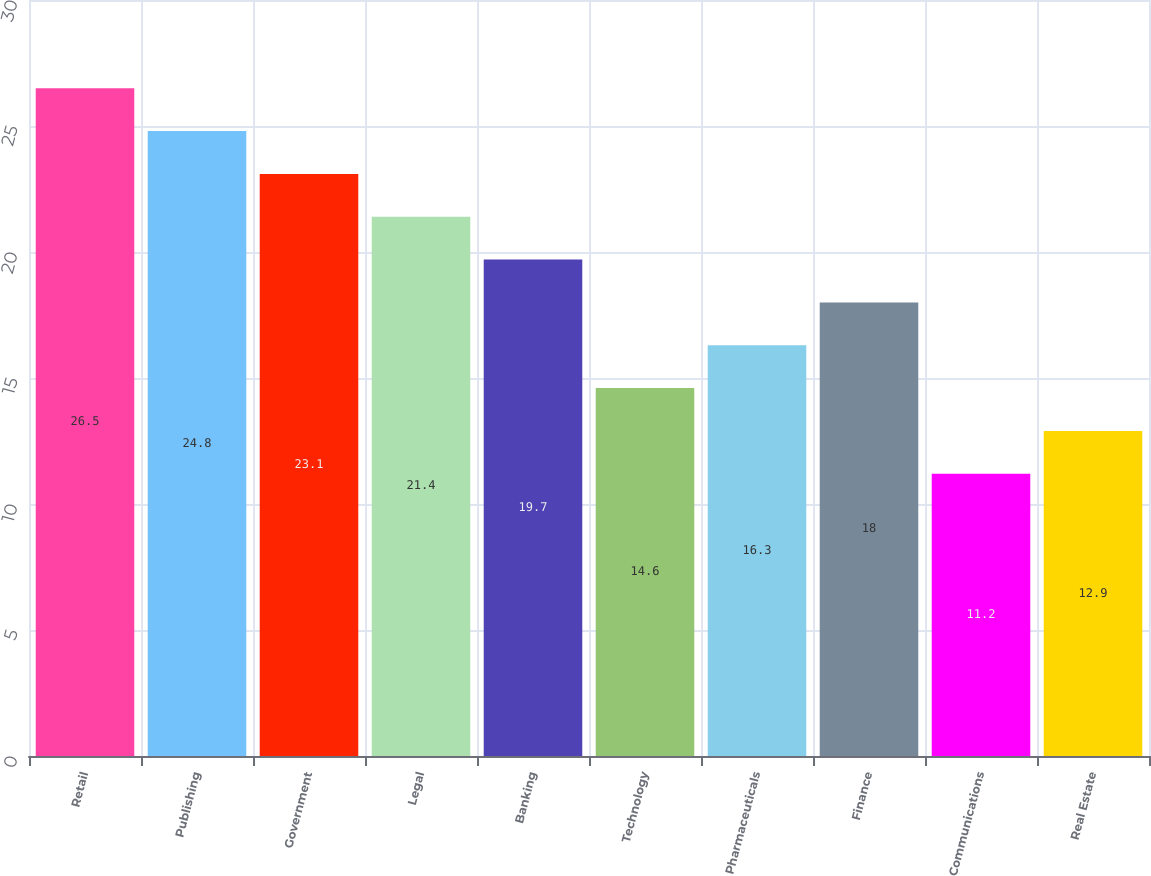<chart> <loc_0><loc_0><loc_500><loc_500><bar_chart><fcel>Retail<fcel>Publishing<fcel>Government<fcel>Legal<fcel>Banking<fcel>Technology<fcel>Pharmaceuticals<fcel>Finance<fcel>Communications<fcel>Real Estate<nl><fcel>26.5<fcel>24.8<fcel>23.1<fcel>21.4<fcel>19.7<fcel>14.6<fcel>16.3<fcel>18<fcel>11.2<fcel>12.9<nl></chart> 